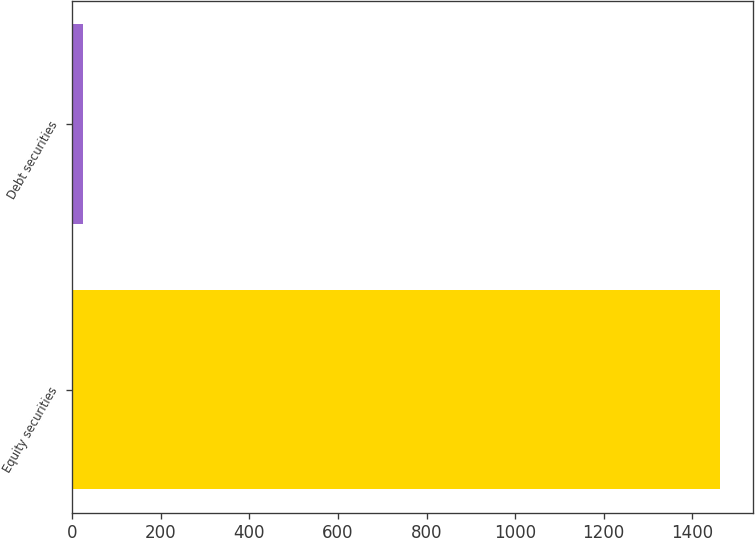<chart> <loc_0><loc_0><loc_500><loc_500><bar_chart><fcel>Equity securities<fcel>Debt securities<nl><fcel>1463<fcel>24<nl></chart> 